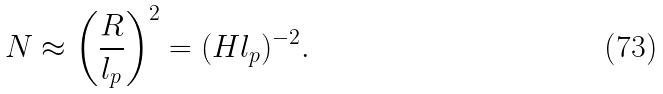Convert formula to latex. <formula><loc_0><loc_0><loc_500><loc_500>N \approx \left ( \frac { R } { l _ { p } } \right ) ^ { 2 } = ( H l _ { p } ) ^ { - 2 } .</formula> 